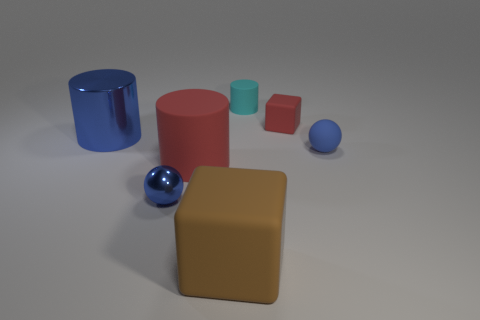Subtract all big cylinders. How many cylinders are left? 1 Subtract all red cylinders. How many cylinders are left? 2 Subtract 1 balls. How many balls are left? 1 Add 1 brown things. How many objects exist? 8 Subtract all cubes. How many objects are left? 5 Add 7 small blue metal objects. How many small blue metal objects are left? 8 Add 1 small cyan rubber cylinders. How many small cyan rubber cylinders exist? 2 Subtract 0 purple cylinders. How many objects are left? 7 Subtract all red cylinders. Subtract all gray blocks. How many cylinders are left? 2 Subtract all brown cylinders. How many yellow cubes are left? 0 